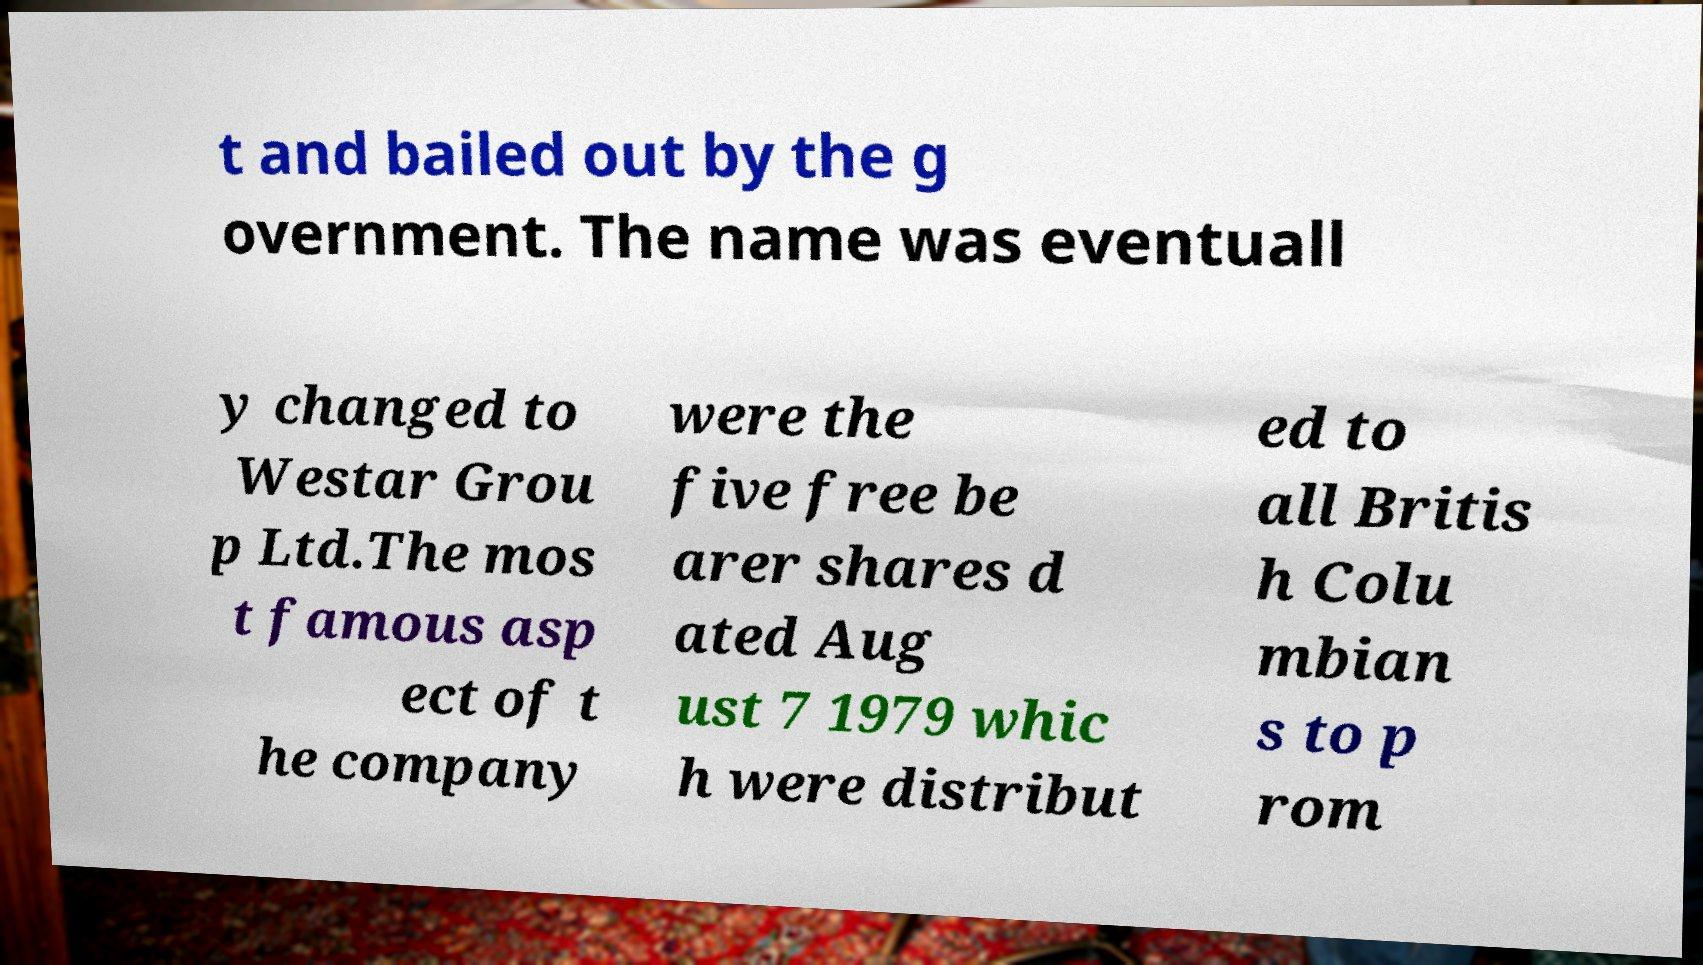Can you accurately transcribe the text from the provided image for me? t and bailed out by the g overnment. The name was eventuall y changed to Westar Grou p Ltd.The mos t famous asp ect of t he company were the five free be arer shares d ated Aug ust 7 1979 whic h were distribut ed to all Britis h Colu mbian s to p rom 